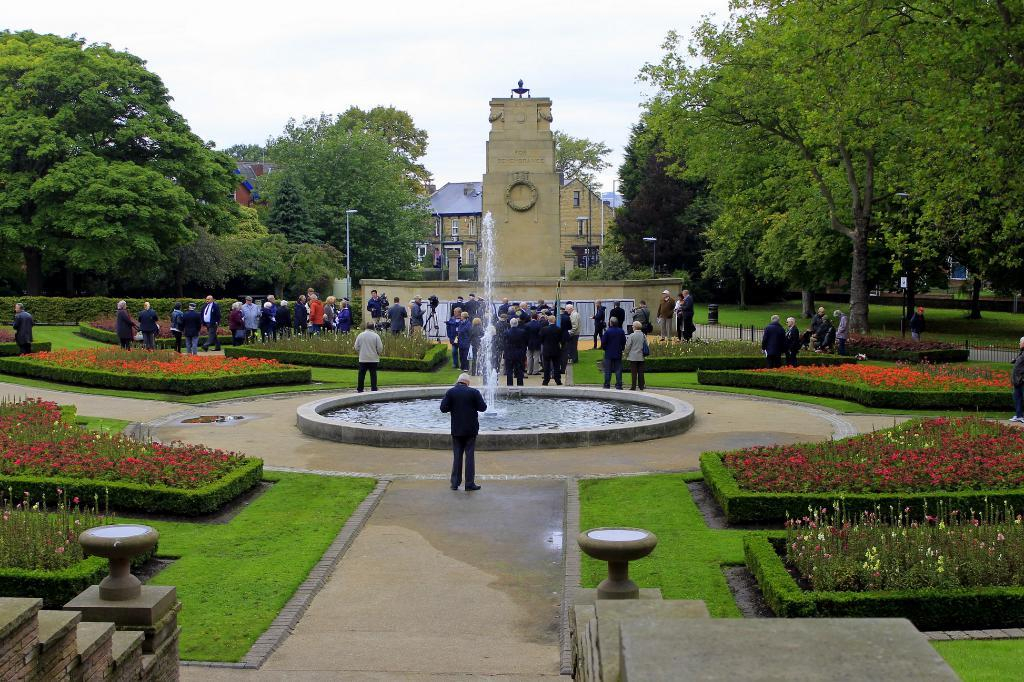What is the main feature in the center of the image? There is a fountain in the center of the image. How many people can be seen in the image? There are many people in the image. What can be seen in the background of the image? There are trees and buildings in the background of the image. What architectural features are present in the front of the image? There are stairs and hedges in the front of the image. What type of glue is being used by the people in the image? There is no glue present in the image, and no indication that people are using glue. How many chickens can be seen in the image? There are no chickens present in the image. 